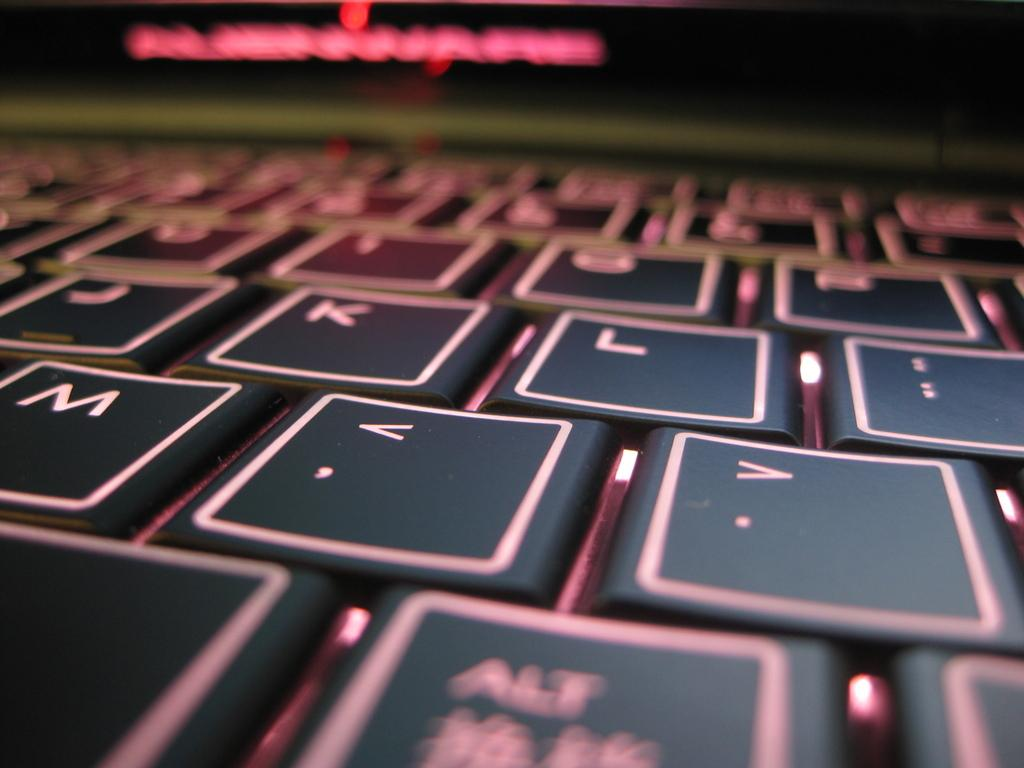<image>
Provide a brief description of the given image. A keyboard's J, K, and L keys are visible and look huge. 